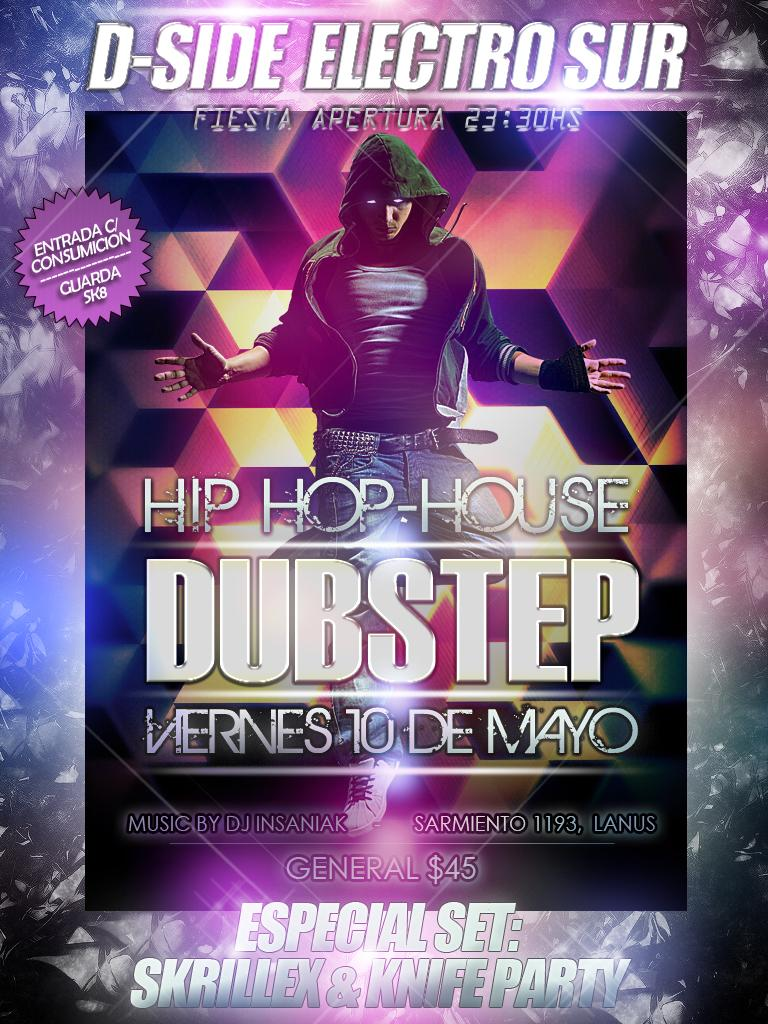<image>
Describe the image concisely. a poster for a hip hop group with D-Side Electro Sur written on the top 